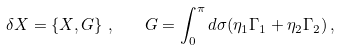Convert formula to latex. <formula><loc_0><loc_0><loc_500><loc_500>\delta X = \left \{ X , G \right \} \, , \quad G = \int _ { 0 } ^ { \pi } d \sigma ( \eta _ { 1 } \Gamma _ { 1 } + \eta _ { 2 } \Gamma _ { 2 } ) \, ,</formula> 